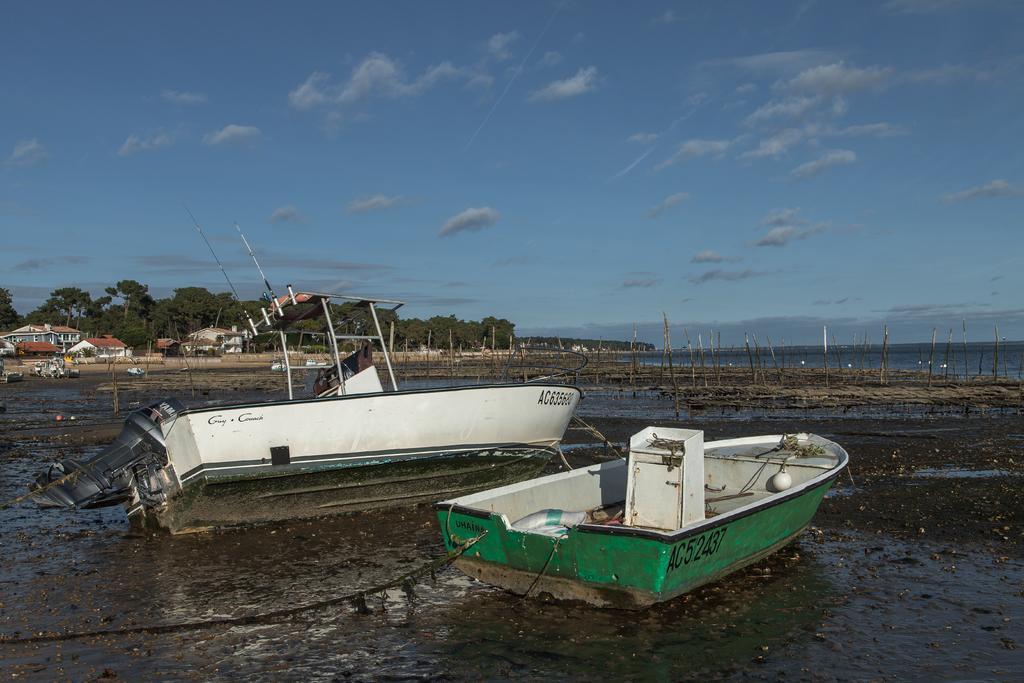Please provide a concise description of this image. In this image there are boats, and at the background there are buildings, trees, sky. 